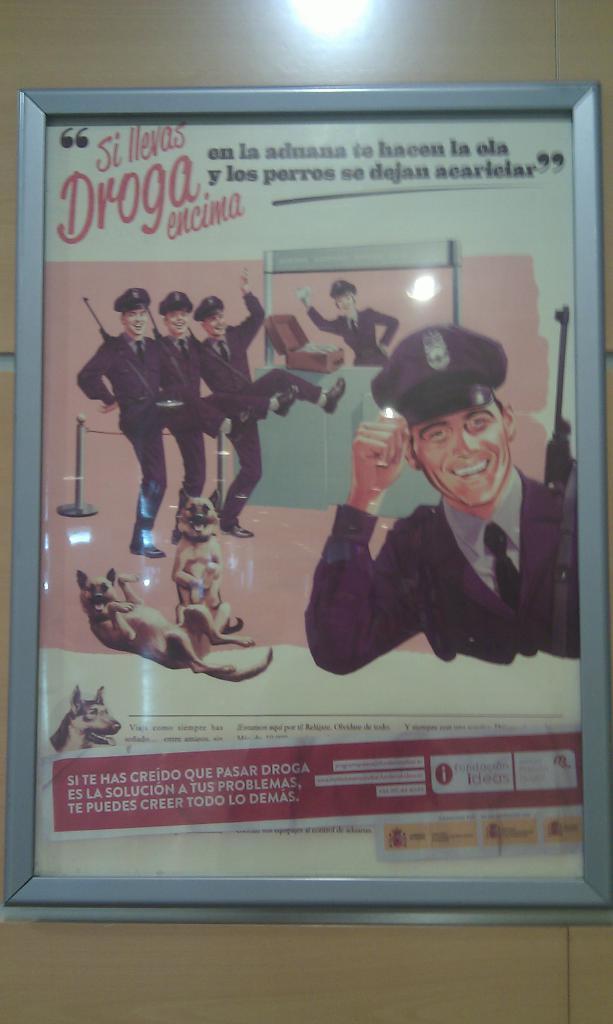Describe this image in one or two sentences. The picture consists of a poster in a frame. At the top there is a light. In the poster there are police officers, dogs and text. 